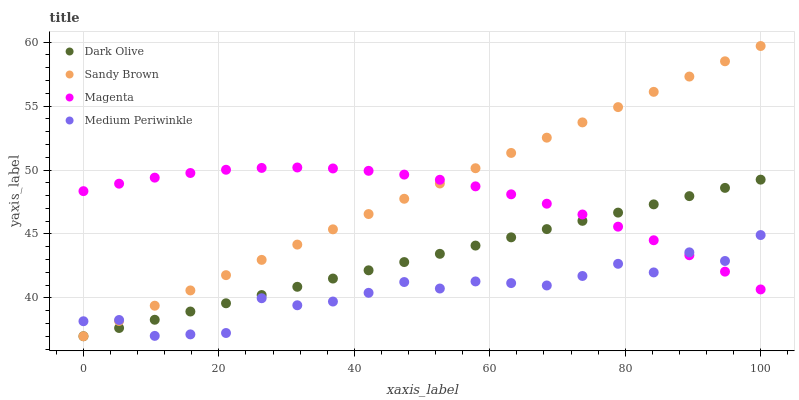Does Medium Periwinkle have the minimum area under the curve?
Answer yes or no. Yes. Does Sandy Brown have the maximum area under the curve?
Answer yes or no. Yes. Does Magenta have the minimum area under the curve?
Answer yes or no. No. Does Magenta have the maximum area under the curve?
Answer yes or no. No. Is Sandy Brown the smoothest?
Answer yes or no. Yes. Is Medium Periwinkle the roughest?
Answer yes or no. Yes. Is Magenta the smoothest?
Answer yes or no. No. Is Magenta the roughest?
Answer yes or no. No. Does Dark Olive have the lowest value?
Answer yes or no. Yes. Does Magenta have the lowest value?
Answer yes or no. No. Does Sandy Brown have the highest value?
Answer yes or no. Yes. Does Magenta have the highest value?
Answer yes or no. No. Does Sandy Brown intersect Medium Periwinkle?
Answer yes or no. Yes. Is Sandy Brown less than Medium Periwinkle?
Answer yes or no. No. Is Sandy Brown greater than Medium Periwinkle?
Answer yes or no. No. 